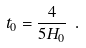Convert formula to latex. <formula><loc_0><loc_0><loc_500><loc_500>t _ { 0 } = \frac { 4 } { 5 H _ { 0 } } \ .</formula> 